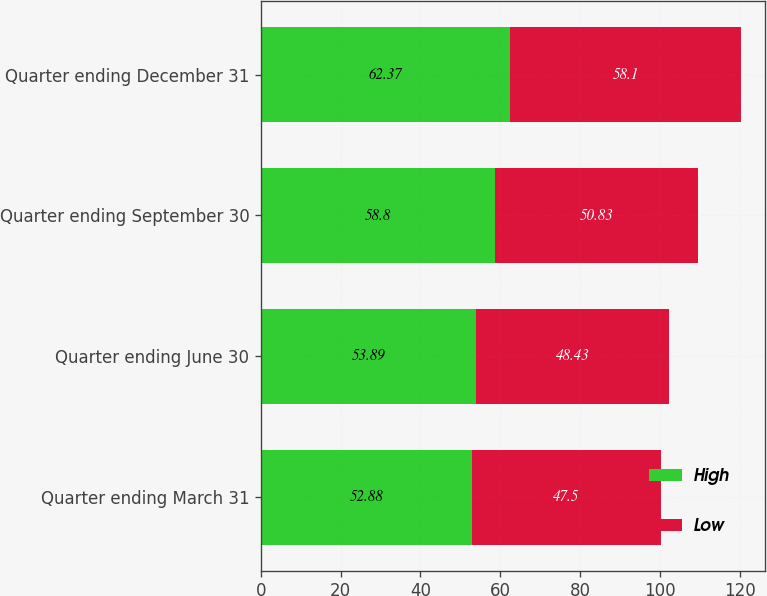<chart> <loc_0><loc_0><loc_500><loc_500><stacked_bar_chart><ecel><fcel>Quarter ending March 31<fcel>Quarter ending June 30<fcel>Quarter ending September 30<fcel>Quarter ending December 31<nl><fcel>High<fcel>52.88<fcel>53.89<fcel>58.8<fcel>62.37<nl><fcel>Low<fcel>47.5<fcel>48.43<fcel>50.83<fcel>58.1<nl></chart> 